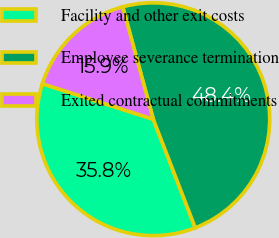Convert chart. <chart><loc_0><loc_0><loc_500><loc_500><pie_chart><fcel>Facility and other exit costs<fcel>Employee severance termination<fcel>Exited contractual commitments<nl><fcel>35.79%<fcel>48.35%<fcel>15.85%<nl></chart> 